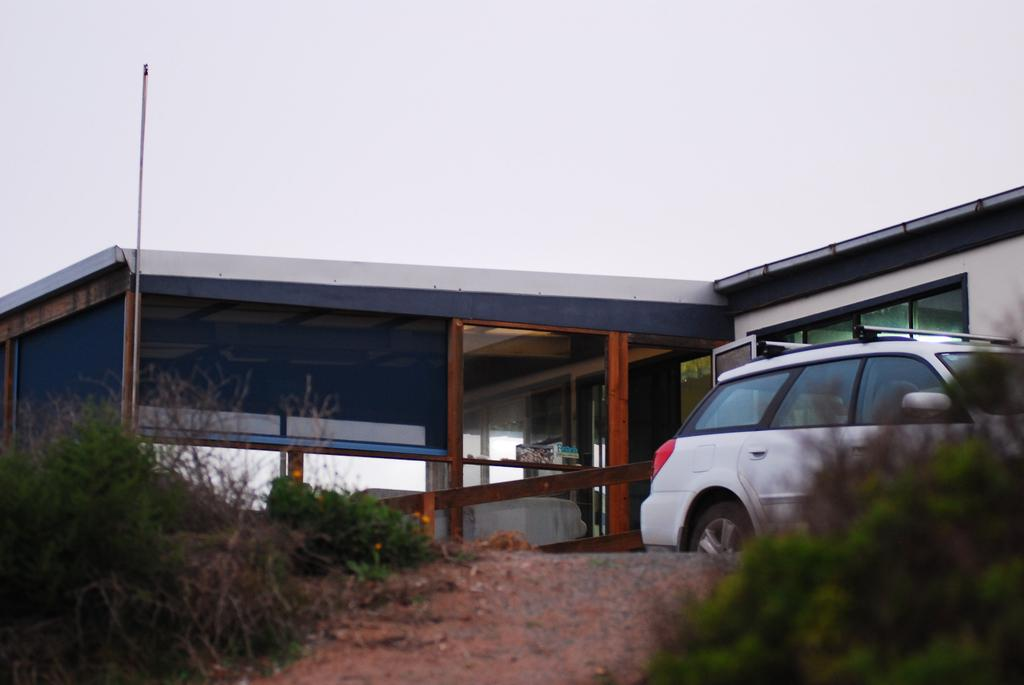What type of vegetation can be seen in the image? There are bushes in the image. What type of vehicle is present in the image? There is a white-colored vehicle in the image. What type of structure is visible in the image? There is a building in the image. What type of throat problem is the person in the image experiencing? There is no person present in the image, so it is not possible to determine if they are experiencing any throat problems. How many birds can be seen in the image? There are no birds visible in the image. 